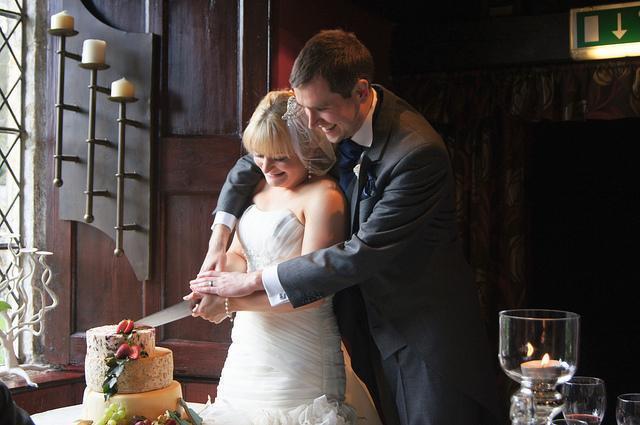What did the pair here recently exchange?
Indicate the correct response and explain using: 'Answer: answer
Rationale: rationale.'
Options: Clothes, moms, cards, rings. Answer: rings.
Rationale: They are cutting their wedding cake while wearing bride and groom attire. 